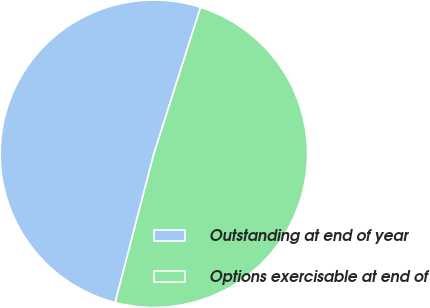Convert chart to OTSL. <chart><loc_0><loc_0><loc_500><loc_500><pie_chart><fcel>Outstanding at end of year<fcel>Options exercisable at end of<nl><fcel>50.86%<fcel>49.14%<nl></chart> 